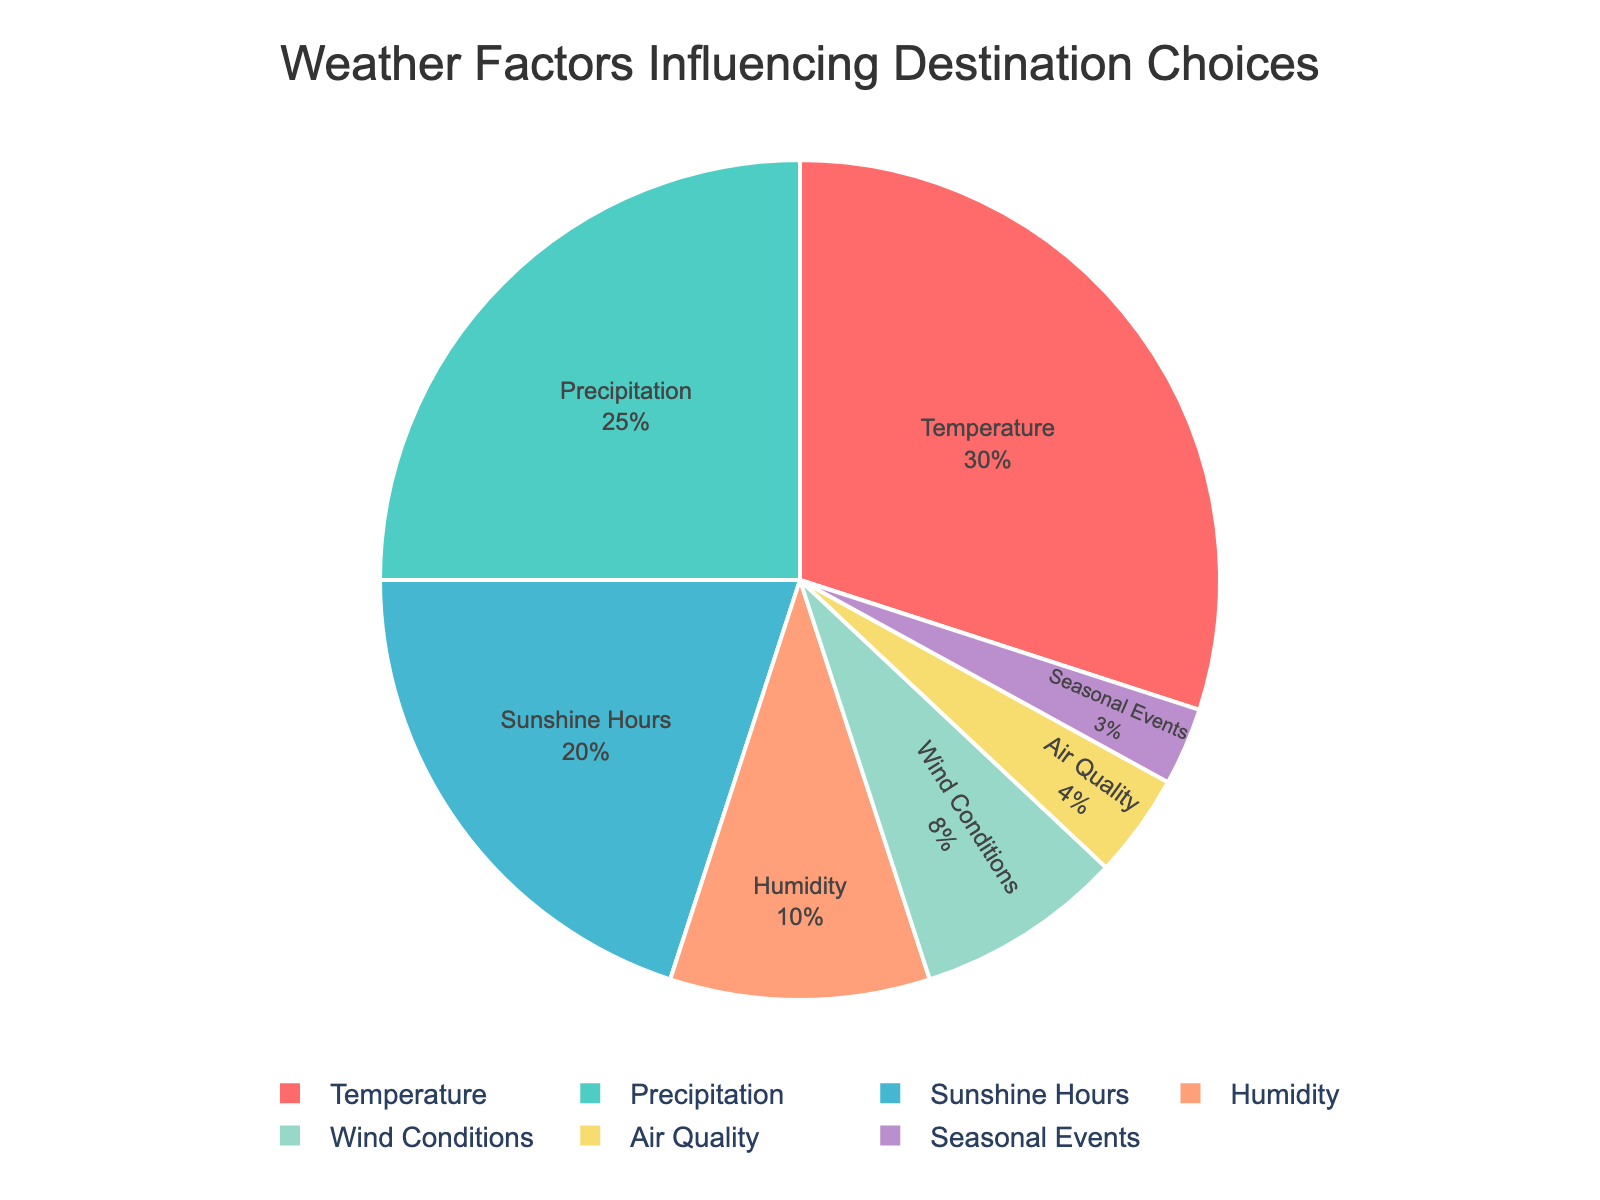What is the factor with the highest percentage? The factor with the highest percentage is the one with the largest slice in the pie chart. Observing the pie chart, "Temperature" has the largest slice.
Answer: Temperature Which factor has a smaller percentage, Humidity or Air Quality? Compare the slices for "Humidity" and "Air Quality" in the pie chart. "Humidity" has a 10% slice, while "Air Quality" has a 4% slice, making "Air Quality" smaller.
Answer: Air Quality What is the combined percentage of Precipitation, Sunshine Hours, and Wind Conditions? Add the percentages for "Precipitation" (25%), "Sunshine Hours" (20%), and "Wind Conditions" (8%). The combined percentage is 25 + 20 + 8 = 53%.
Answer: 53% Which factors together make up the majority of the choices? A majority is over 50%. Add the largest percentages starting from the top: Temperature (30%) + Precipitation (25%) = 55%. So, the majority consists of "Temperature" and "Precipitation".
Answer: Temperature and Precipitation Is the sum of Seasonal Events and Air Quality greater than the percentage of Wind Conditions? Calculate the sum of "Seasonal Events" (3%) and "Air Quality" (4%), which is 3 + 4 = 7%. Compare this to "Wind Conditions" at 8%. 7% is less than 8%.
Answer: No What color represents the "Humidity" slice in the pie chart? Look for the slice labeled "Humidity" and note its color. The color assigned to "Humidity" is a distinctive shade used in the chart.
Answer: Blue By how much does the percentage of Sunshine Hours exceed that of Seasonal Events? Subtract the percentage of "Seasonal Events" (3%) from "Sunshine Hours" (20%). The difference is 20 - 3 = 17%.
Answer: 17% Which factors contribute equally to the combined percentage of Air Quality and Wind Conditions? Calculate the combined percentage of "Air Quality" (4%) and "Wind Conditions" (8%), which is 4 + 8 = 12%. Check if any other factors add up to the same 12%. "Humidity" (10%) and "Seasonal Events" (3%) near this sum but not exactly 12%. No exact match.
Answer: None 